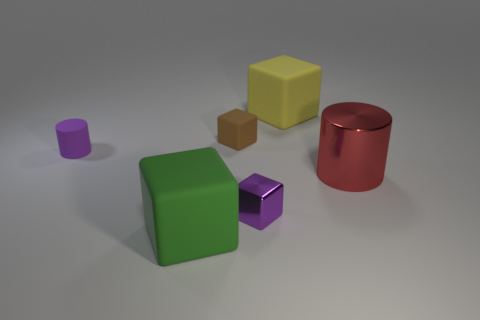Add 2 tiny rubber spheres. How many objects exist? 8 Subtract all cylinders. How many objects are left? 4 Subtract 1 yellow cubes. How many objects are left? 5 Subtract all large red cylinders. Subtract all big metal objects. How many objects are left? 4 Add 2 green matte things. How many green matte things are left? 3 Add 6 large green cubes. How many large green cubes exist? 7 